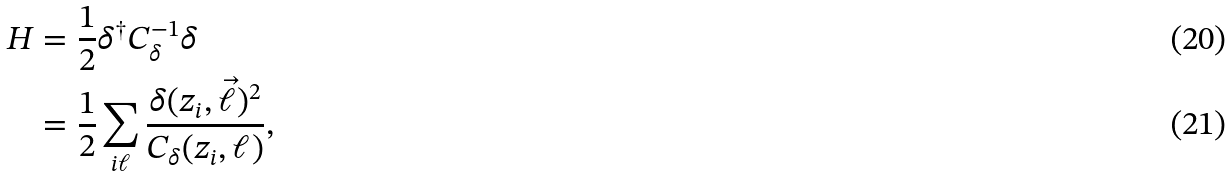<formula> <loc_0><loc_0><loc_500><loc_500>H & = \frac { 1 } { 2 } \delta ^ { \dag } { C } ^ { - 1 } _ { \delta } \delta \\ & = \frac { 1 } { 2 } \sum _ { i \ell } \frac { \delta ( z _ { i } , \vec { \ell } ) ^ { 2 } } { C _ { \delta } ( z _ { i } , \ell ) } ,</formula> 